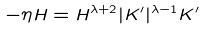Convert formula to latex. <formula><loc_0><loc_0><loc_500><loc_500>- \eta H = H ^ { \lambda + 2 } | K ^ { \prime } | ^ { \lambda - 1 } K ^ { \prime }</formula> 